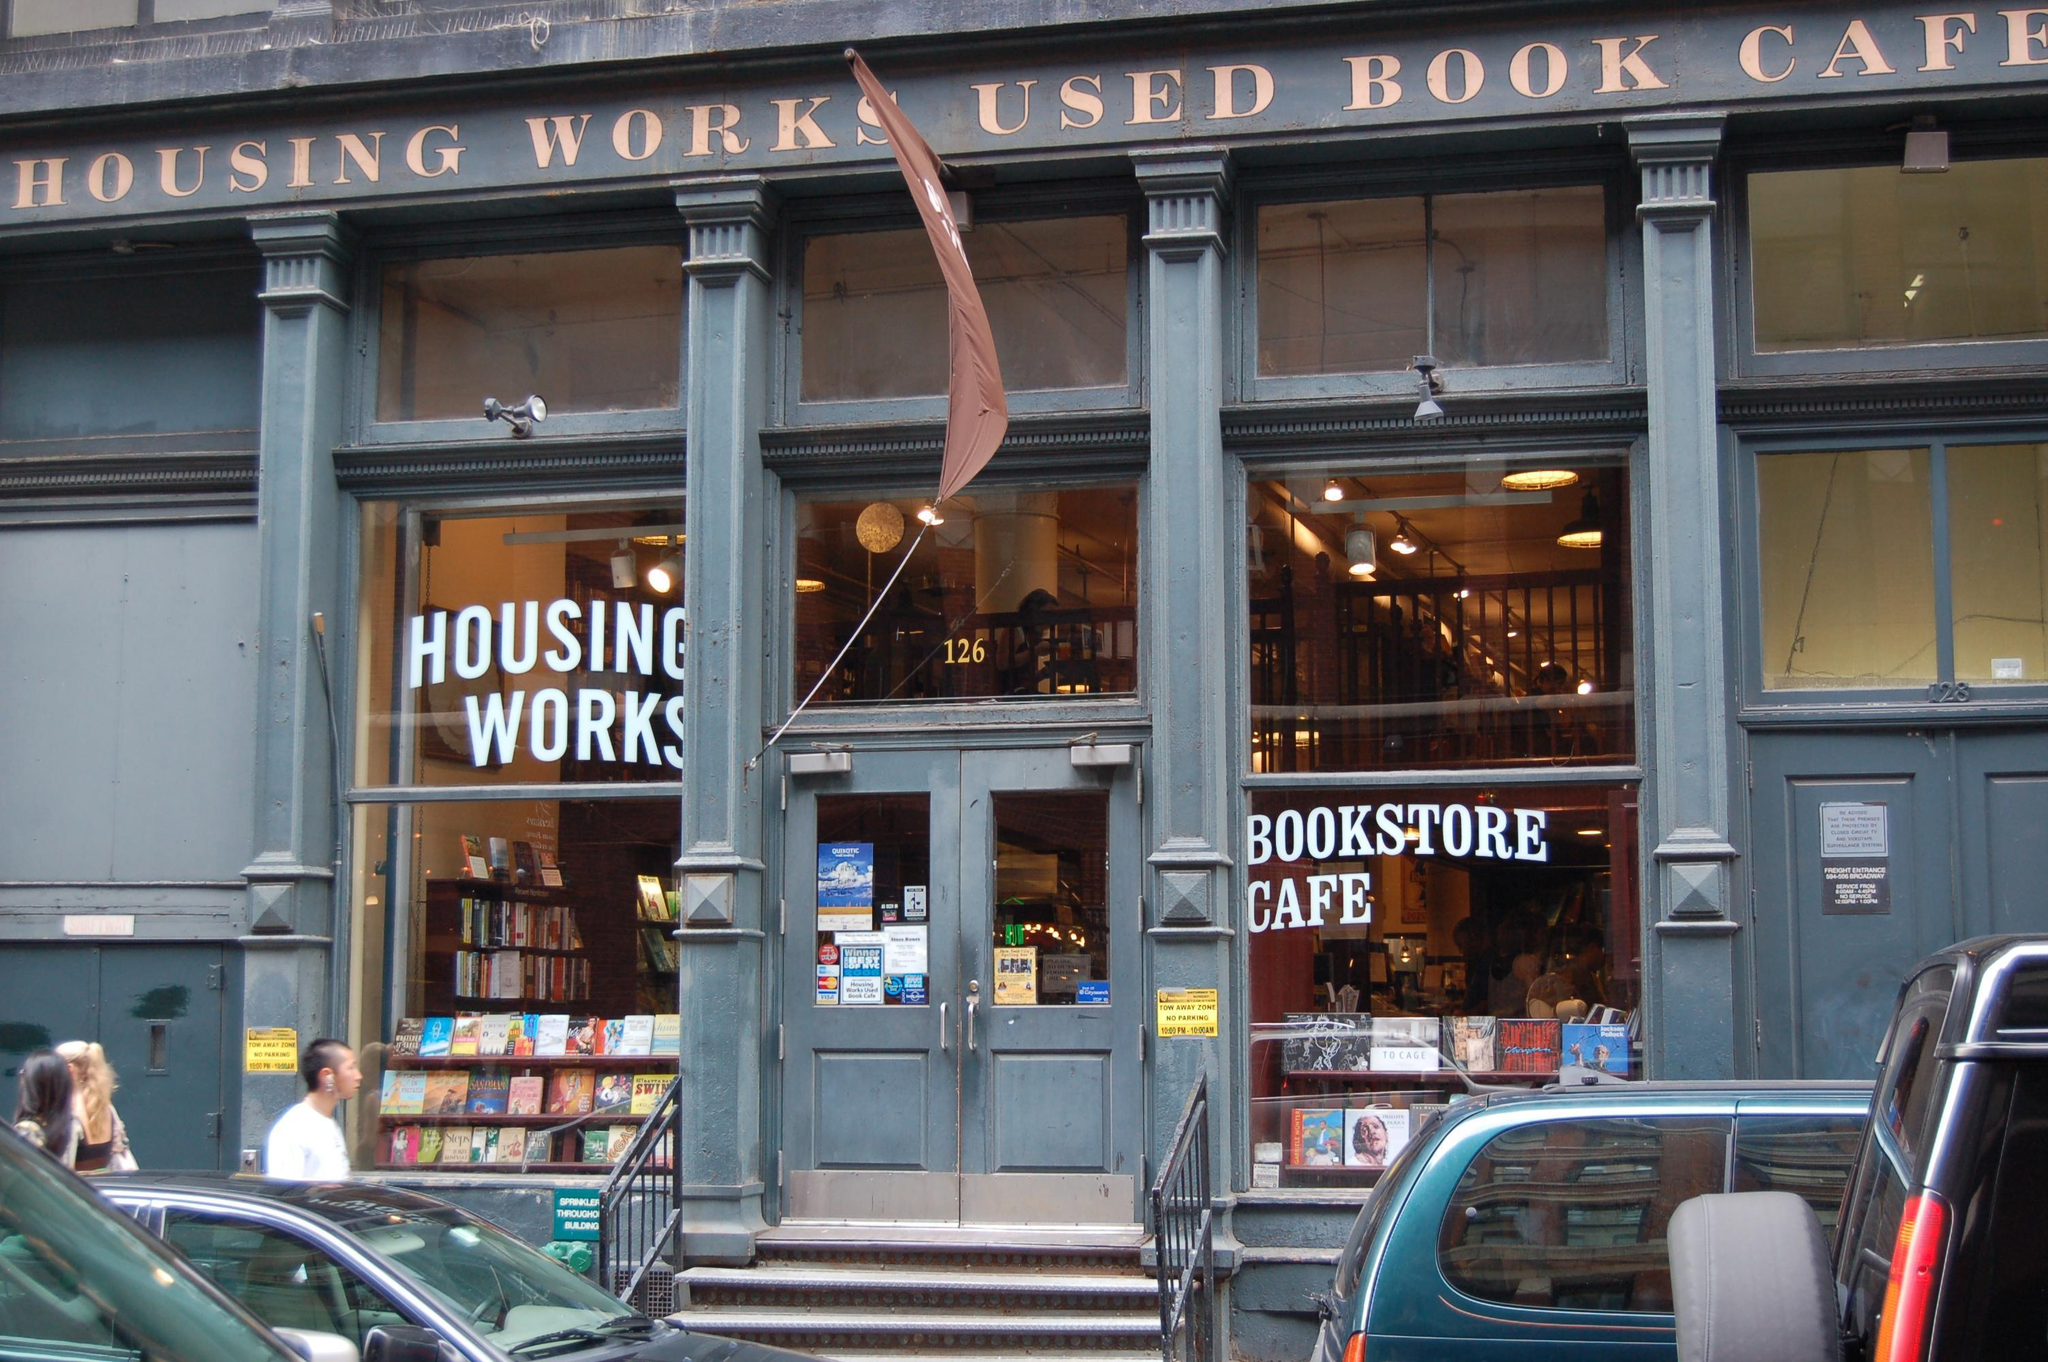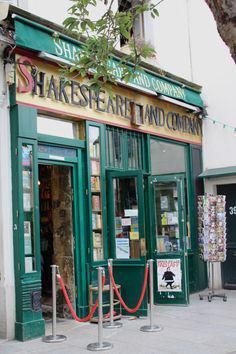The first image is the image on the left, the second image is the image on the right. For the images displayed, is the sentence "The book shops pictured in the images on the left and right have the same color paint on their exterior, and at least one shop has windows divided into small panes." factually correct? Answer yes or no. No. The first image is the image on the left, the second image is the image on the right. Evaluate the accuracy of this statement regarding the images: "There are at least two green paint frames at the entrance of a bookstore.". Is it true? Answer yes or no. Yes. 